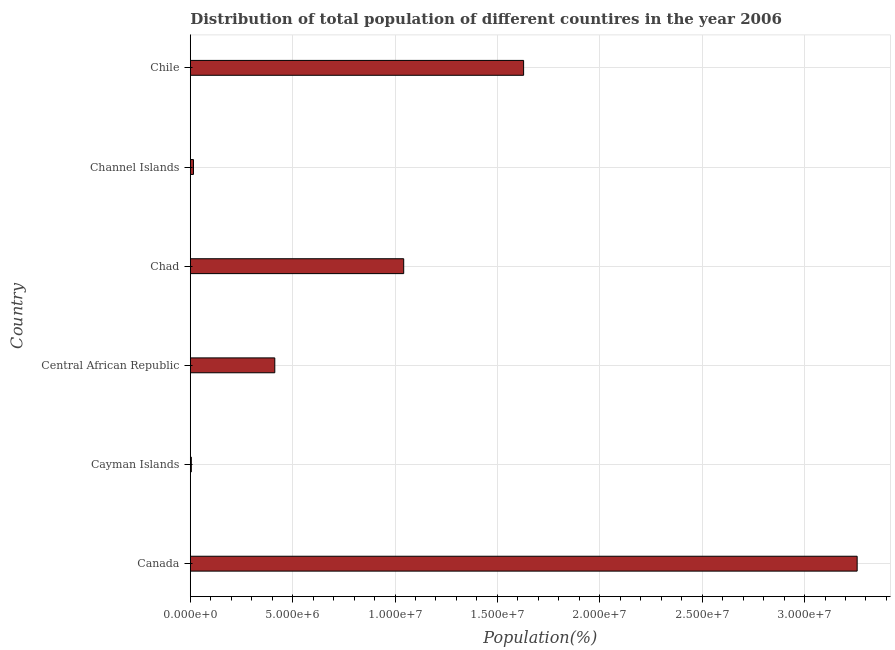Does the graph contain grids?
Your answer should be compact. Yes. What is the title of the graph?
Give a very brief answer. Distribution of total population of different countires in the year 2006. What is the label or title of the X-axis?
Offer a very short reply. Population(%). What is the label or title of the Y-axis?
Provide a short and direct response. Country. What is the population in Chad?
Make the answer very short. 1.04e+07. Across all countries, what is the maximum population?
Keep it short and to the point. 3.26e+07. Across all countries, what is the minimum population?
Make the answer very short. 5.00e+04. In which country was the population minimum?
Provide a short and direct response. Cayman Islands. What is the sum of the population?
Your response must be concise. 6.36e+07. What is the difference between the population in Cayman Islands and Chad?
Offer a very short reply. -1.04e+07. What is the average population per country?
Keep it short and to the point. 1.06e+07. What is the median population?
Keep it short and to the point. 7.28e+06. In how many countries, is the population greater than 25000000 %?
Your response must be concise. 1. What is the ratio of the population in Cayman Islands to that in Central African Republic?
Your response must be concise. 0.01. Is the population in Canada less than that in Chad?
Keep it short and to the point. No. Is the difference between the population in Canada and Channel Islands greater than the difference between any two countries?
Offer a very short reply. No. What is the difference between the highest and the second highest population?
Make the answer very short. 1.63e+07. What is the difference between the highest and the lowest population?
Offer a terse response. 3.25e+07. Are all the bars in the graph horizontal?
Your answer should be very brief. Yes. What is the difference between two consecutive major ticks on the X-axis?
Provide a short and direct response. 5.00e+06. Are the values on the major ticks of X-axis written in scientific E-notation?
Provide a short and direct response. Yes. What is the Population(%) in Canada?
Your response must be concise. 3.26e+07. What is the Population(%) in Cayman Islands?
Offer a very short reply. 5.00e+04. What is the Population(%) of Central African Republic?
Provide a succinct answer. 4.13e+06. What is the Population(%) of Chad?
Your answer should be compact. 1.04e+07. What is the Population(%) in Channel Islands?
Make the answer very short. 1.55e+05. What is the Population(%) in Chile?
Your answer should be very brief. 1.63e+07. What is the difference between the Population(%) in Canada and Cayman Islands?
Your answer should be very brief. 3.25e+07. What is the difference between the Population(%) in Canada and Central African Republic?
Keep it short and to the point. 2.84e+07. What is the difference between the Population(%) in Canada and Chad?
Keep it short and to the point. 2.21e+07. What is the difference between the Population(%) in Canada and Channel Islands?
Your response must be concise. 3.24e+07. What is the difference between the Population(%) in Canada and Chile?
Make the answer very short. 1.63e+07. What is the difference between the Population(%) in Cayman Islands and Central African Republic?
Ensure brevity in your answer.  -4.08e+06. What is the difference between the Population(%) in Cayman Islands and Chad?
Offer a terse response. -1.04e+07. What is the difference between the Population(%) in Cayman Islands and Channel Islands?
Provide a succinct answer. -1.05e+05. What is the difference between the Population(%) in Cayman Islands and Chile?
Ensure brevity in your answer.  -1.62e+07. What is the difference between the Population(%) in Central African Republic and Chad?
Your answer should be very brief. -6.30e+06. What is the difference between the Population(%) in Central African Republic and Channel Islands?
Keep it short and to the point. 3.97e+06. What is the difference between the Population(%) in Central African Republic and Chile?
Your answer should be very brief. -1.22e+07. What is the difference between the Population(%) in Chad and Channel Islands?
Your answer should be compact. 1.03e+07. What is the difference between the Population(%) in Chad and Chile?
Provide a succinct answer. -5.86e+06. What is the difference between the Population(%) in Channel Islands and Chile?
Provide a short and direct response. -1.61e+07. What is the ratio of the Population(%) in Canada to that in Cayman Islands?
Ensure brevity in your answer.  651.05. What is the ratio of the Population(%) in Canada to that in Central African Republic?
Offer a terse response. 7.89. What is the ratio of the Population(%) in Canada to that in Chad?
Give a very brief answer. 3.12. What is the ratio of the Population(%) in Canada to that in Channel Islands?
Your response must be concise. 209.57. What is the ratio of the Population(%) in Canada to that in Chile?
Your answer should be compact. 2. What is the ratio of the Population(%) in Cayman Islands to that in Central African Republic?
Ensure brevity in your answer.  0.01. What is the ratio of the Population(%) in Cayman Islands to that in Chad?
Your response must be concise. 0.01. What is the ratio of the Population(%) in Cayman Islands to that in Channel Islands?
Your answer should be compact. 0.32. What is the ratio of the Population(%) in Cayman Islands to that in Chile?
Provide a short and direct response. 0. What is the ratio of the Population(%) in Central African Republic to that in Chad?
Offer a terse response. 0.4. What is the ratio of the Population(%) in Central African Republic to that in Channel Islands?
Your answer should be compact. 26.55. What is the ratio of the Population(%) in Central African Republic to that in Chile?
Your response must be concise. 0.25. What is the ratio of the Population(%) in Chad to that in Channel Islands?
Give a very brief answer. 67.07. What is the ratio of the Population(%) in Chad to that in Chile?
Provide a succinct answer. 0.64. What is the ratio of the Population(%) in Channel Islands to that in Chile?
Give a very brief answer. 0.01. 